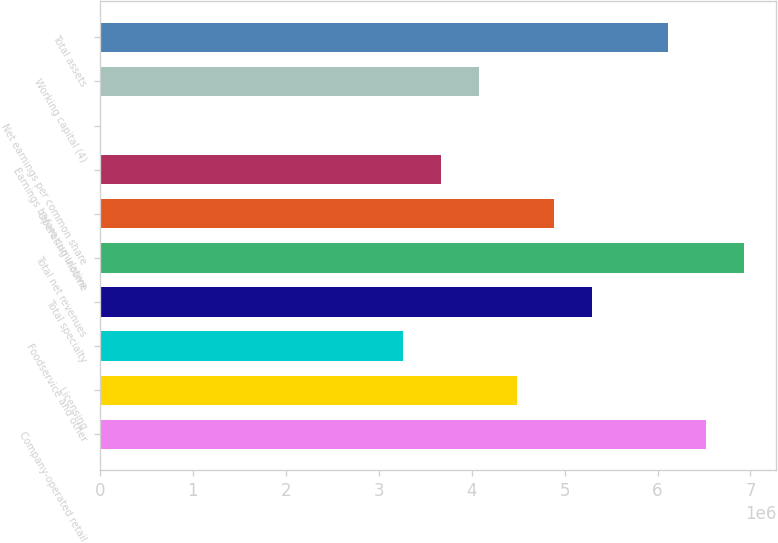Convert chart. <chart><loc_0><loc_0><loc_500><loc_500><bar_chart><fcel>Company-operated retail<fcel>Licensing<fcel>Foodservice and other<fcel>Total specialty<fcel>Total net revenues<fcel>Operating income<fcel>Earnings before cumulative<fcel>Net earnings per common share<fcel>Working capital (4)<fcel>Total assets<nl><fcel>6.52084e+06<fcel>4.48307e+06<fcel>3.26042e+06<fcel>5.29818e+06<fcel>6.92839e+06<fcel>4.89063e+06<fcel>3.66797e+06<fcel>0.33<fcel>4.07552e+06<fcel>6.11328e+06<nl></chart> 